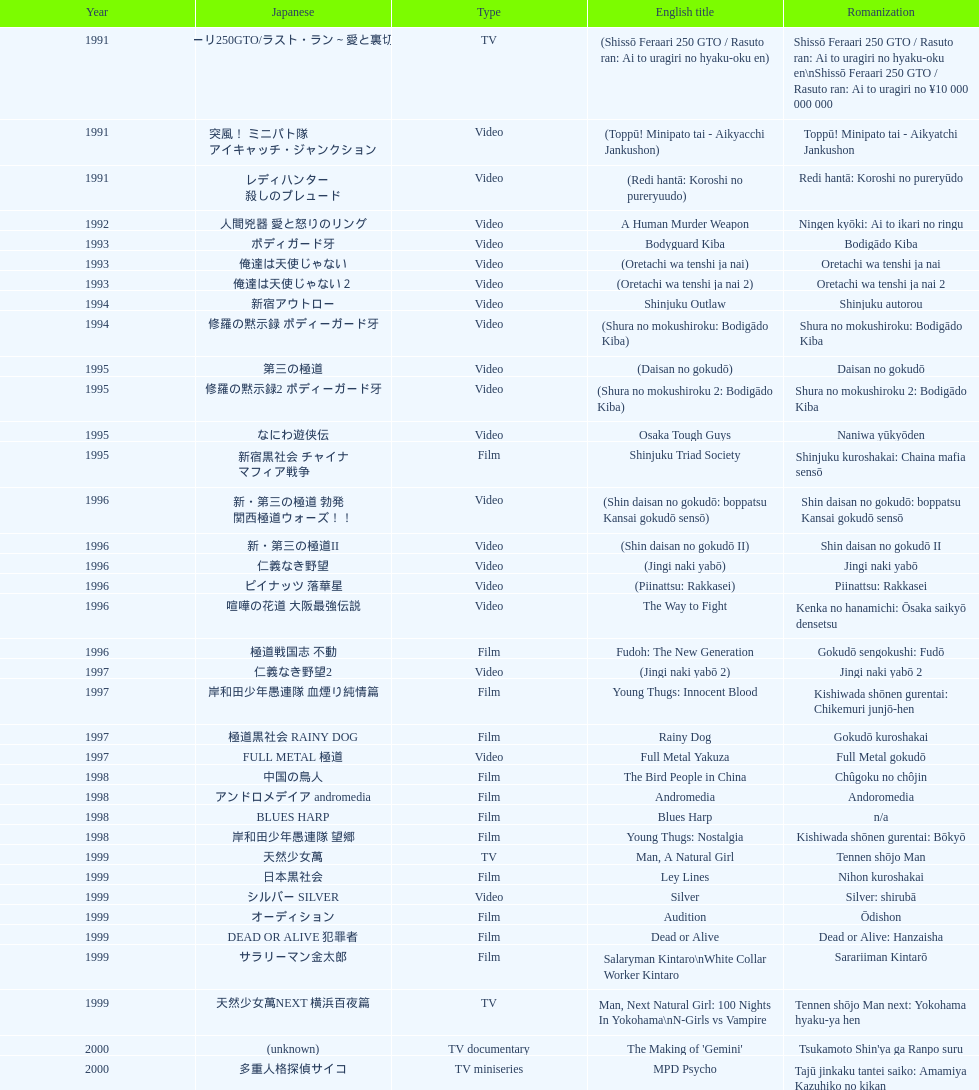Was shinjuku triad society a film or tv release? Film. 